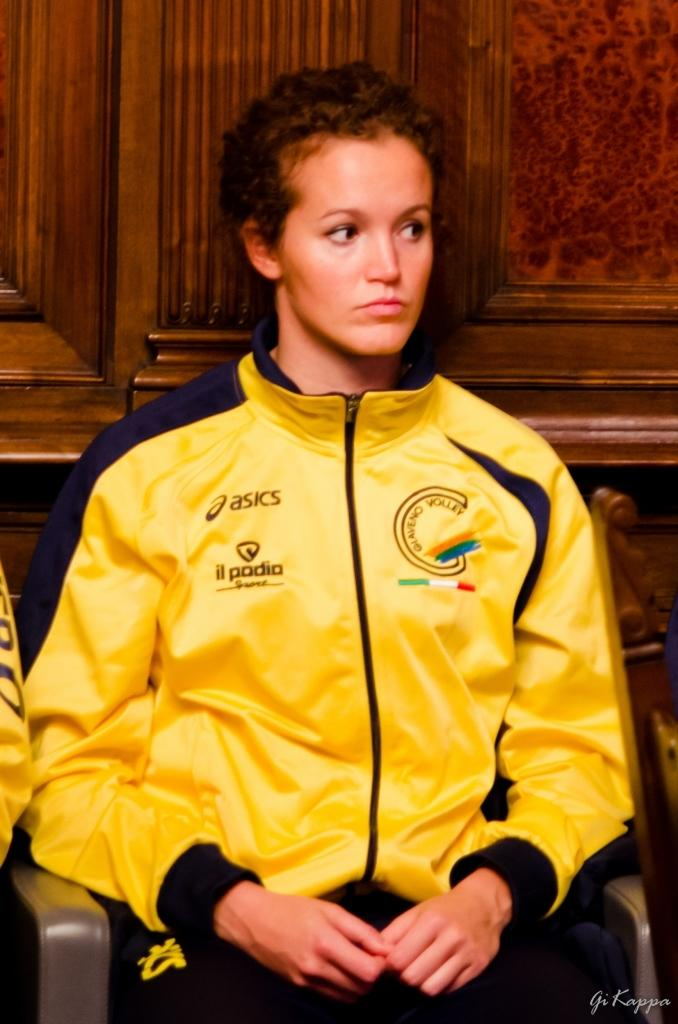Provide a one-sentence caption for the provided image. Yellow Oasics jacket with  il padia design on the left side. 